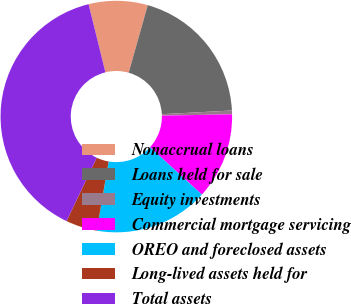Convert chart. <chart><loc_0><loc_0><loc_500><loc_500><pie_chart><fcel>Nonaccrual loans<fcel>Loans held for sale<fcel>Equity investments<fcel>Commercial mortgage servicing<fcel>OREO and foreclosed assets<fcel>Long-lived assets held for<fcel>Total assets<nl><fcel>8.23%<fcel>19.79%<fcel>0.52%<fcel>12.08%<fcel>15.94%<fcel>4.37%<fcel>39.07%<nl></chart> 